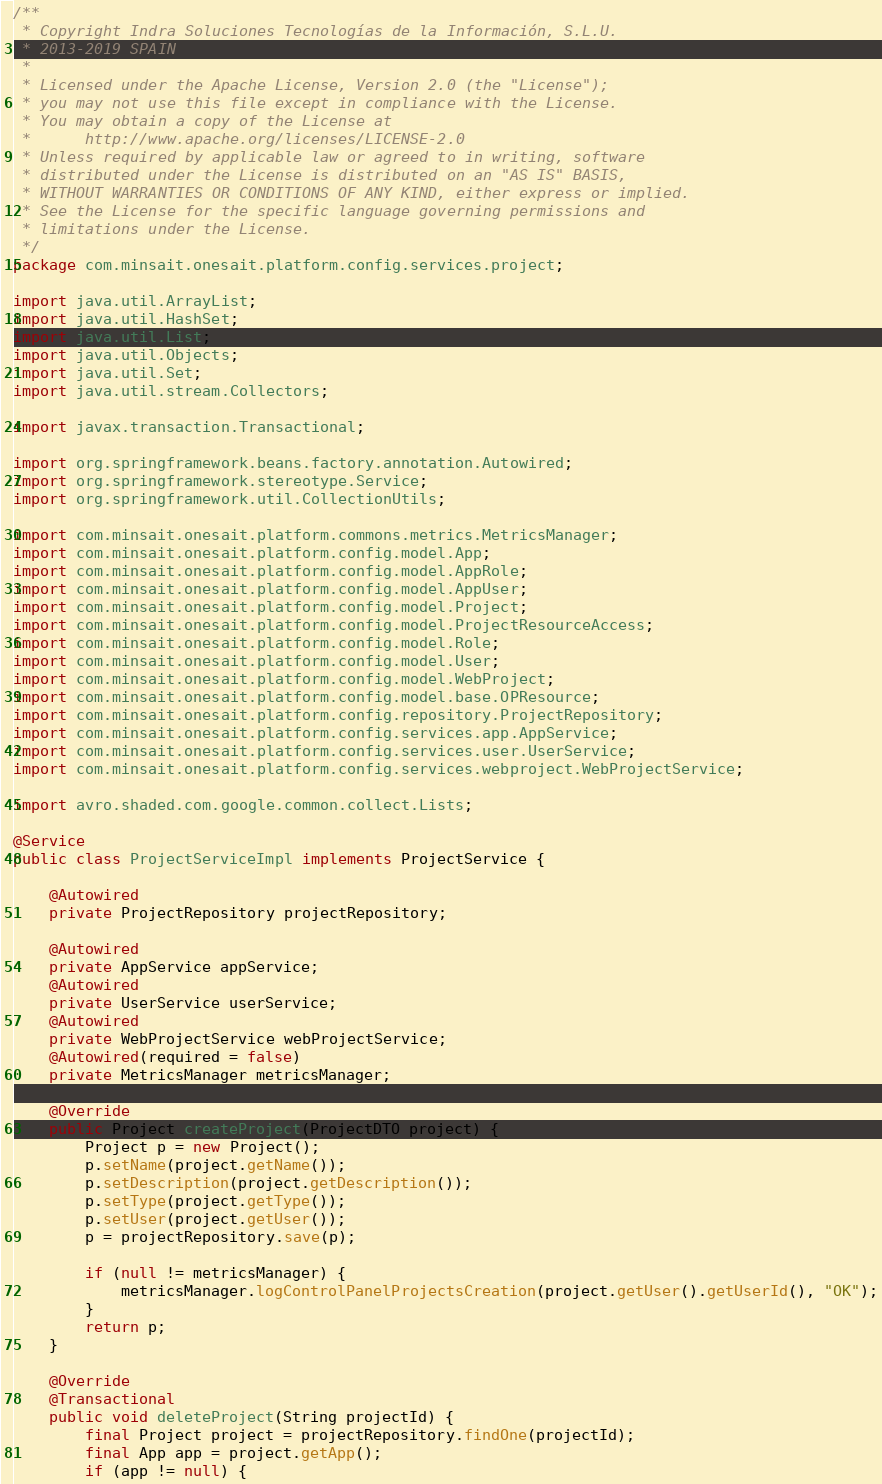Convert code to text. <code><loc_0><loc_0><loc_500><loc_500><_Java_>/**
 * Copyright Indra Soluciones Tecnologías de la Información, S.L.U.
 * 2013-2019 SPAIN
 *
 * Licensed under the Apache License, Version 2.0 (the "License");
 * you may not use this file except in compliance with the License.
 * You may obtain a copy of the License at
 *      http://www.apache.org/licenses/LICENSE-2.0
 * Unless required by applicable law or agreed to in writing, software
 * distributed under the License is distributed on an "AS IS" BASIS,
 * WITHOUT WARRANTIES OR CONDITIONS OF ANY KIND, either express or implied.
 * See the License for the specific language governing permissions and
 * limitations under the License.
 */
package com.minsait.onesait.platform.config.services.project;

import java.util.ArrayList;
import java.util.HashSet;
import java.util.List;
import java.util.Objects;
import java.util.Set;
import java.util.stream.Collectors;

import javax.transaction.Transactional;

import org.springframework.beans.factory.annotation.Autowired;
import org.springframework.stereotype.Service;
import org.springframework.util.CollectionUtils;

import com.minsait.onesait.platform.commons.metrics.MetricsManager;
import com.minsait.onesait.platform.config.model.App;
import com.minsait.onesait.platform.config.model.AppRole;
import com.minsait.onesait.platform.config.model.AppUser;
import com.minsait.onesait.platform.config.model.Project;
import com.minsait.onesait.platform.config.model.ProjectResourceAccess;
import com.minsait.onesait.platform.config.model.Role;
import com.minsait.onesait.platform.config.model.User;
import com.minsait.onesait.platform.config.model.WebProject;
import com.minsait.onesait.platform.config.model.base.OPResource;
import com.minsait.onesait.platform.config.repository.ProjectRepository;
import com.minsait.onesait.platform.config.services.app.AppService;
import com.minsait.onesait.platform.config.services.user.UserService;
import com.minsait.onesait.platform.config.services.webproject.WebProjectService;

import avro.shaded.com.google.common.collect.Lists;

@Service
public class ProjectServiceImpl implements ProjectService {

	@Autowired
	private ProjectRepository projectRepository;

	@Autowired
	private AppService appService;
	@Autowired
	private UserService userService;
	@Autowired
	private WebProjectService webProjectService;
	@Autowired(required = false)
	private MetricsManager metricsManager;

	@Override
	public Project createProject(ProjectDTO project) {
		Project p = new Project();
		p.setName(project.getName());
		p.setDescription(project.getDescription());
		p.setType(project.getType());
		p.setUser(project.getUser());
		p = projectRepository.save(p);

		if (null != metricsManager) {
			metricsManager.logControlPanelProjectsCreation(project.getUser().getUserId(), "OK");
		}
		return p;
	}

	@Override
	@Transactional
	public void deleteProject(String projectId) {
		final Project project = projectRepository.findOne(projectId);
		final App app = project.getApp();
		if (app != null) {</code> 